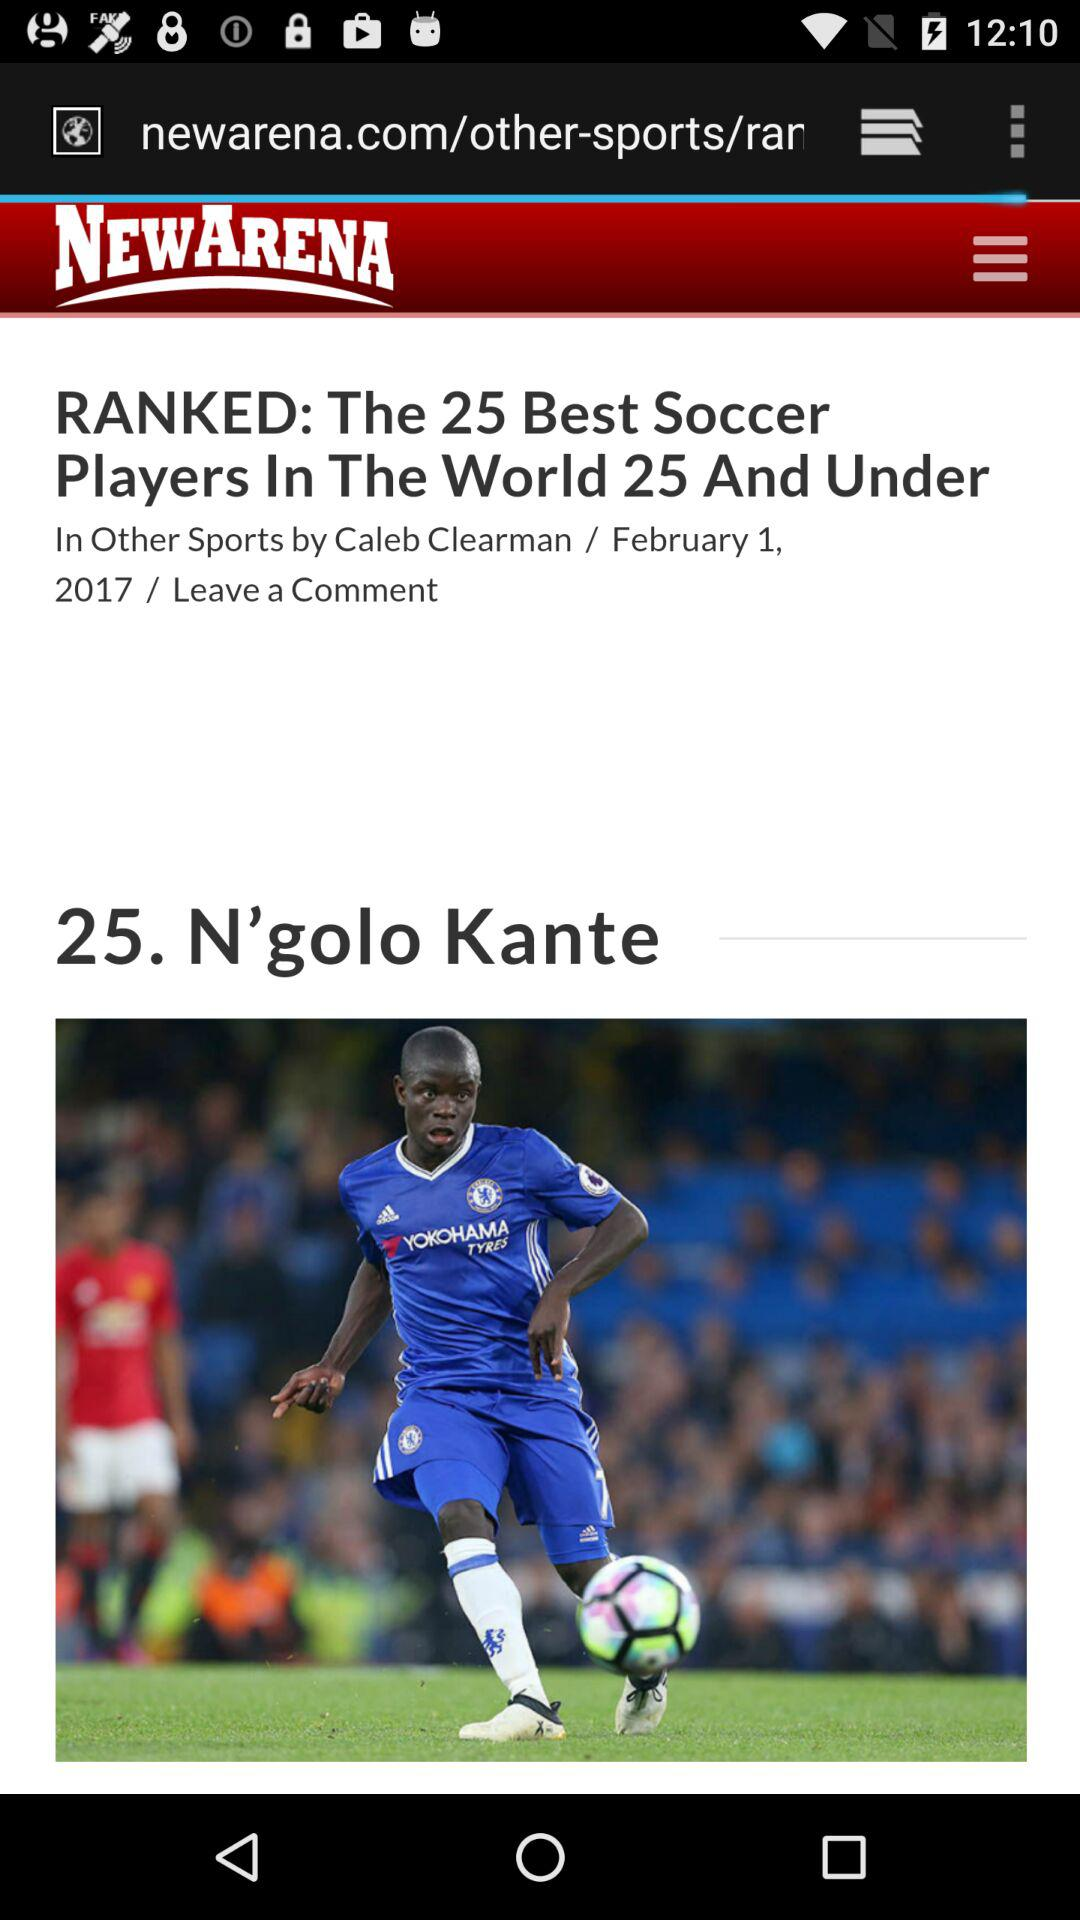What is the name of the application? The application name is "NEWARENA". 